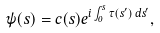Convert formula to latex. <formula><loc_0><loc_0><loc_500><loc_500>\psi ( s ) = c ( s ) e ^ { i \int _ { 0 } ^ { s } \tau ( s ^ { \prime } ) \, d s ^ { \prime } } ,</formula> 